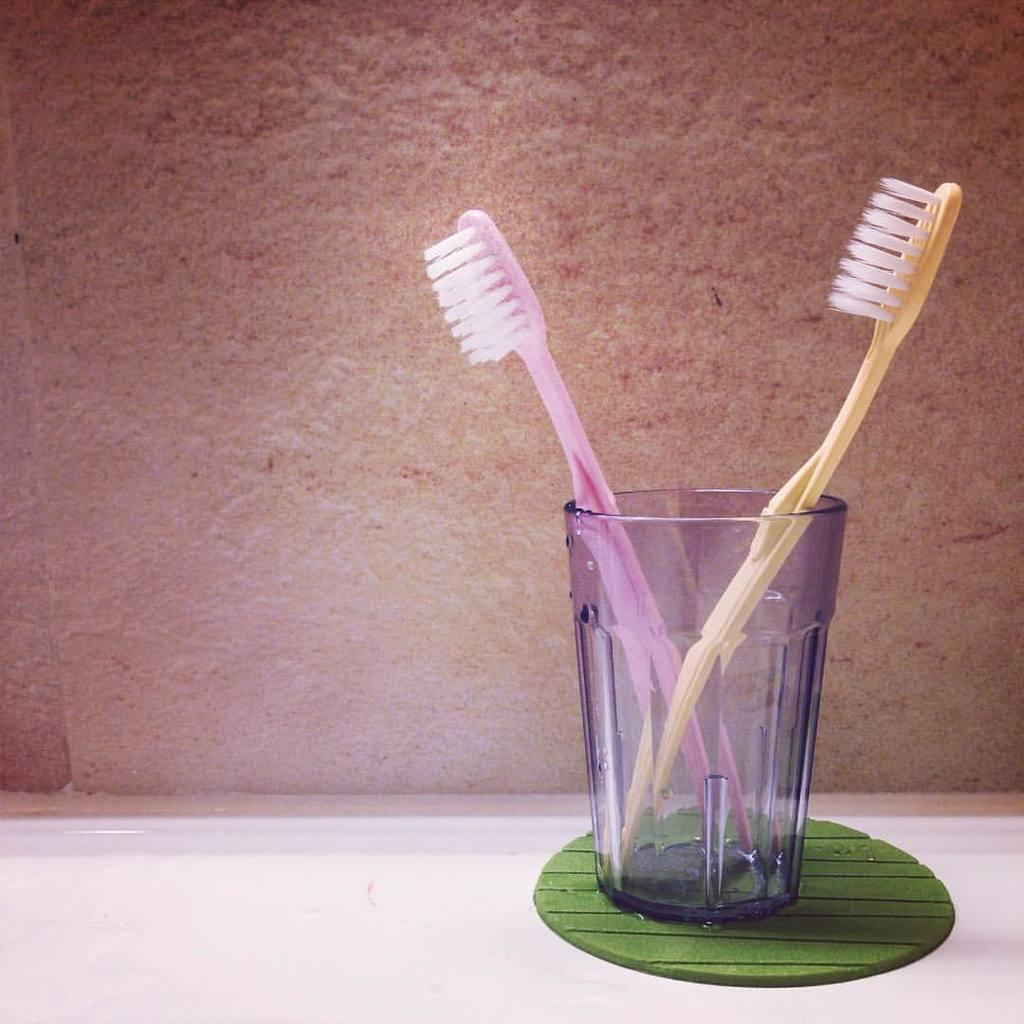What can be seen in the background of the image? There is a wall in the background of the image. What is the main object in the image? There is a platform in the image. What are the toothbrushes doing on the platform? The toothbrushes are in a glass holder on the platform. Can you describe the glass in the image? There is a glass on an object in the image. What type of pipe is visible in the image? There is no pipe present in the image. Can you describe the tramp in the image? There is no tramp present in the image. 